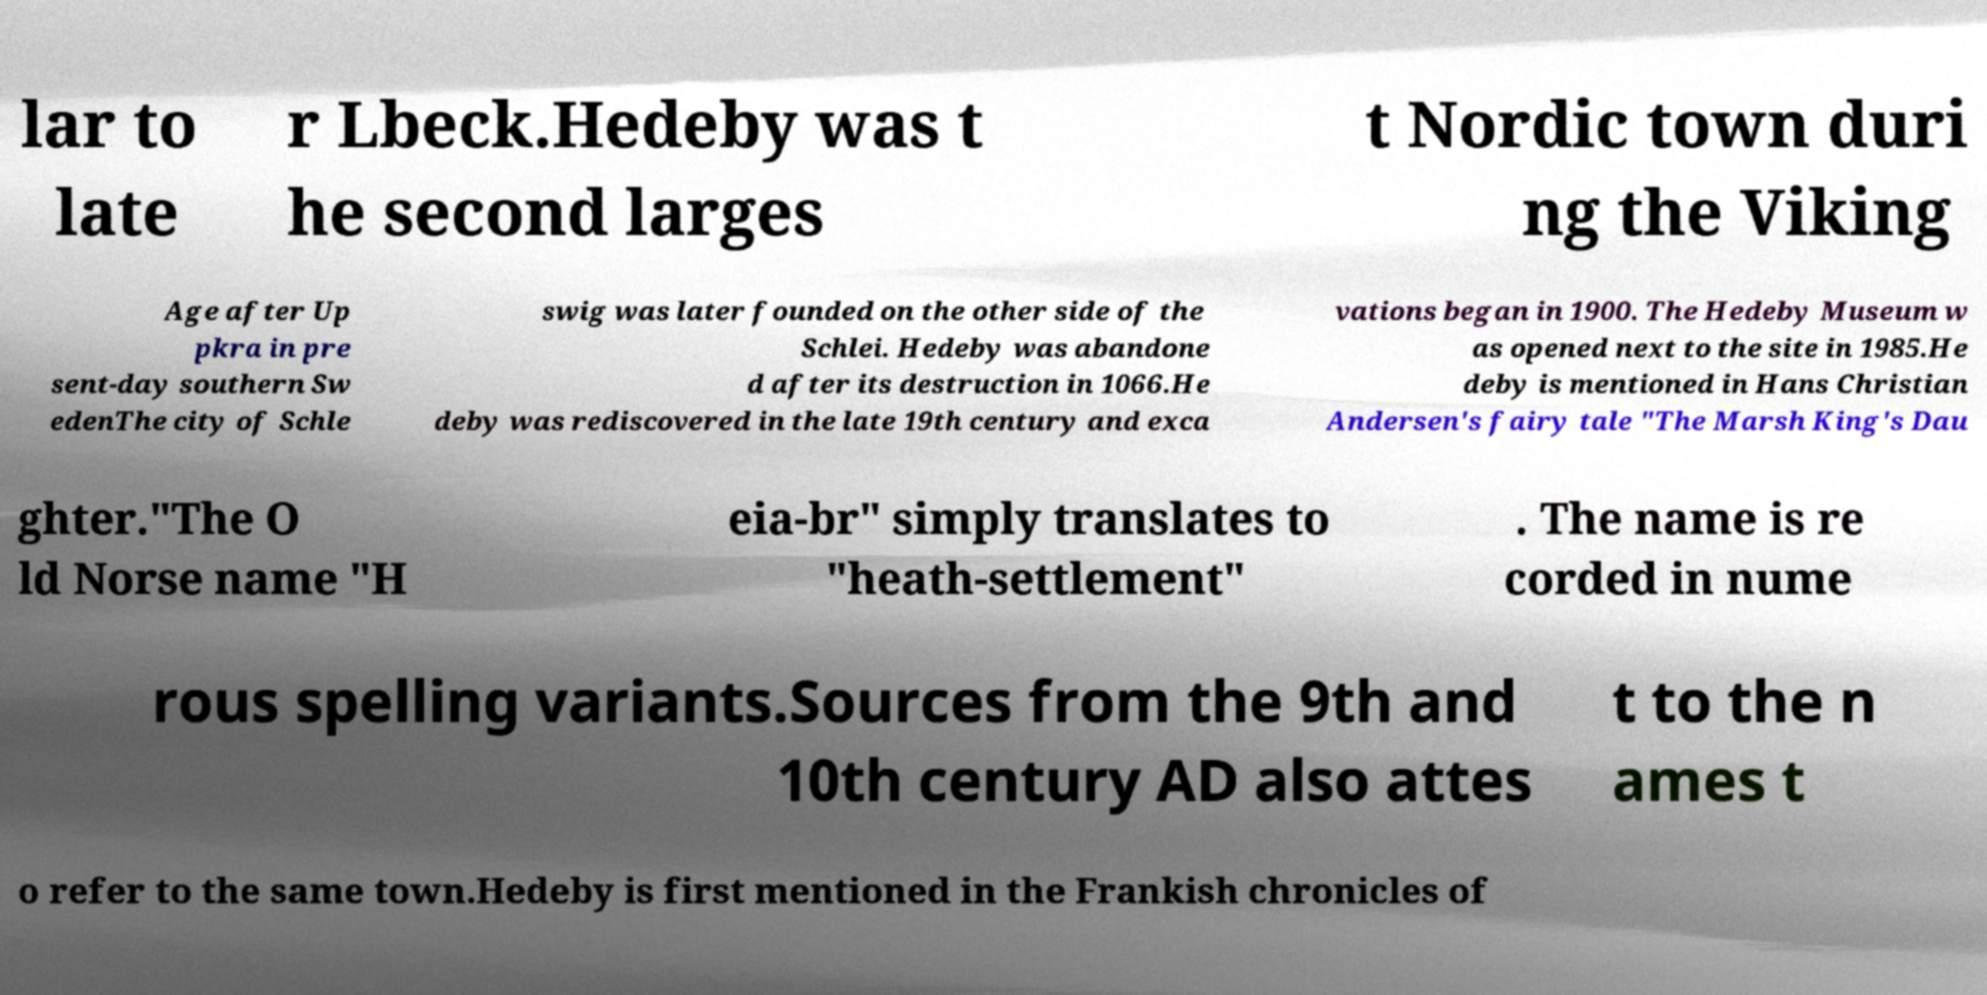For documentation purposes, I need the text within this image transcribed. Could you provide that? lar to late r Lbeck.Hedeby was t he second larges t Nordic town duri ng the Viking Age after Up pkra in pre sent-day southern Sw edenThe city of Schle swig was later founded on the other side of the Schlei. Hedeby was abandone d after its destruction in 1066.He deby was rediscovered in the late 19th century and exca vations began in 1900. The Hedeby Museum w as opened next to the site in 1985.He deby is mentioned in Hans Christian Andersen's fairy tale "The Marsh King's Dau ghter."The O ld Norse name "H eia-br" simply translates to "heath-settlement" . The name is re corded in nume rous spelling variants.Sources from the 9th and 10th century AD also attes t to the n ames t o refer to the same town.Hedeby is first mentioned in the Frankish chronicles of 